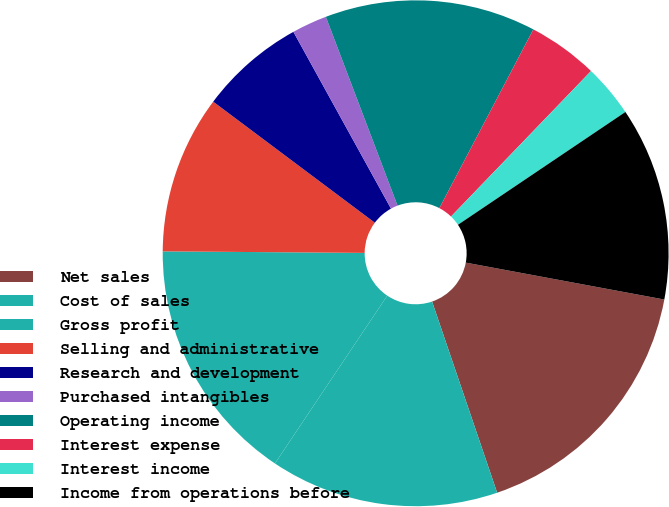Convert chart to OTSL. <chart><loc_0><loc_0><loc_500><loc_500><pie_chart><fcel>Net sales<fcel>Cost of sales<fcel>Gross profit<fcel>Selling and administrative<fcel>Research and development<fcel>Purchased intangibles<fcel>Operating income<fcel>Interest expense<fcel>Interest income<fcel>Income from operations before<nl><fcel>16.85%<fcel>14.61%<fcel>15.73%<fcel>10.11%<fcel>6.74%<fcel>2.25%<fcel>13.48%<fcel>4.49%<fcel>3.37%<fcel>12.36%<nl></chart> 